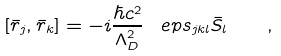Convert formula to latex. <formula><loc_0><loc_0><loc_500><loc_500>[ \bar { r } _ { j } , \bar { r } _ { k } ] = - i \frac { \hbar { c } ^ { 2 } } { \Lambda _ { D } ^ { 2 } } \, \ e p s _ { j k l } \bar { S } _ { l } \quad ,</formula> 